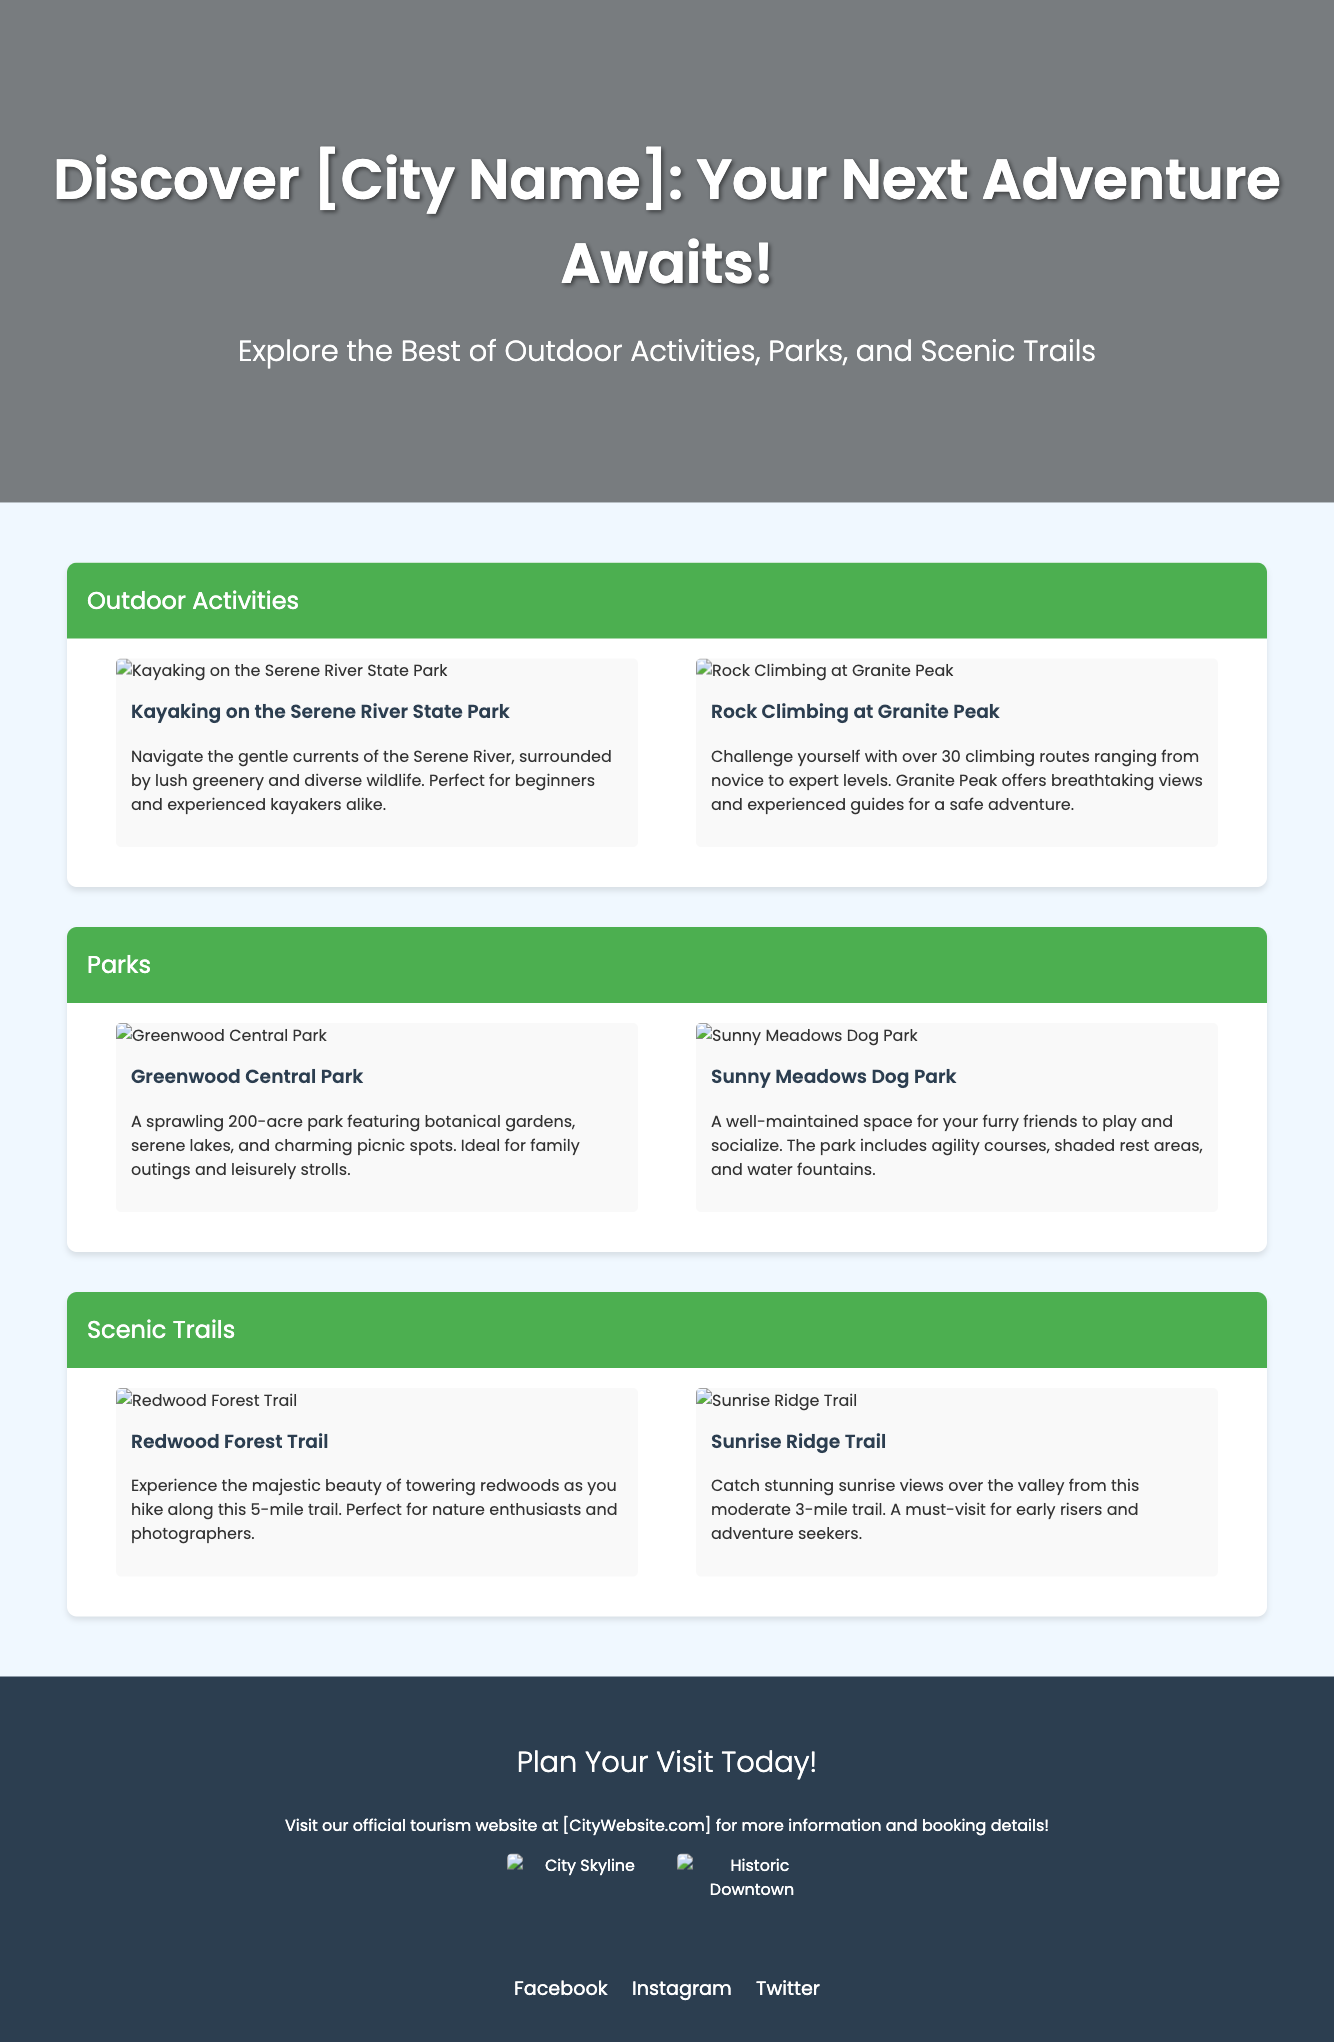What is the title of the advertisement? The title appears prominently at the top of the document and invites readers to explore adventure in the city.
Answer: Discover [City Name]: Your Next Adventure Awaits! How many outdoor activities are featured in the document? The document lists specific outdoor activities, highlighting at least two activities under each section.
Answer: 2 What park is mentioned for family outings? The document describes a particular park ideal for family activities, located under the parks section.
Answer: Greenwood Central Park How long is the Redwood Forest Trail? The length of this scenic hiking trail is explicitly stated in the document.
Answer: 5 miles What kind of views can be experienced from Sunrise Ridge Trail? The document provides information about the type of views available from this trail, described in an appealing way.
Answer: Stunning sunrise views Which social media platforms are mentioned for more information? The footer lists specific platforms readers can follow for updates and information about city tourism.
Answer: Facebook, Instagram, Twitter What type of activities can be done at Sunny Meadows Dog Park? The document specifies the nature of activities available, particularly for pets.
Answer: Play and socialize What is the main theme of the advertisement? The overall message and purpose of this advertisement can be identified based on its sections and content.
Answer: Outdoor activities and adventure 